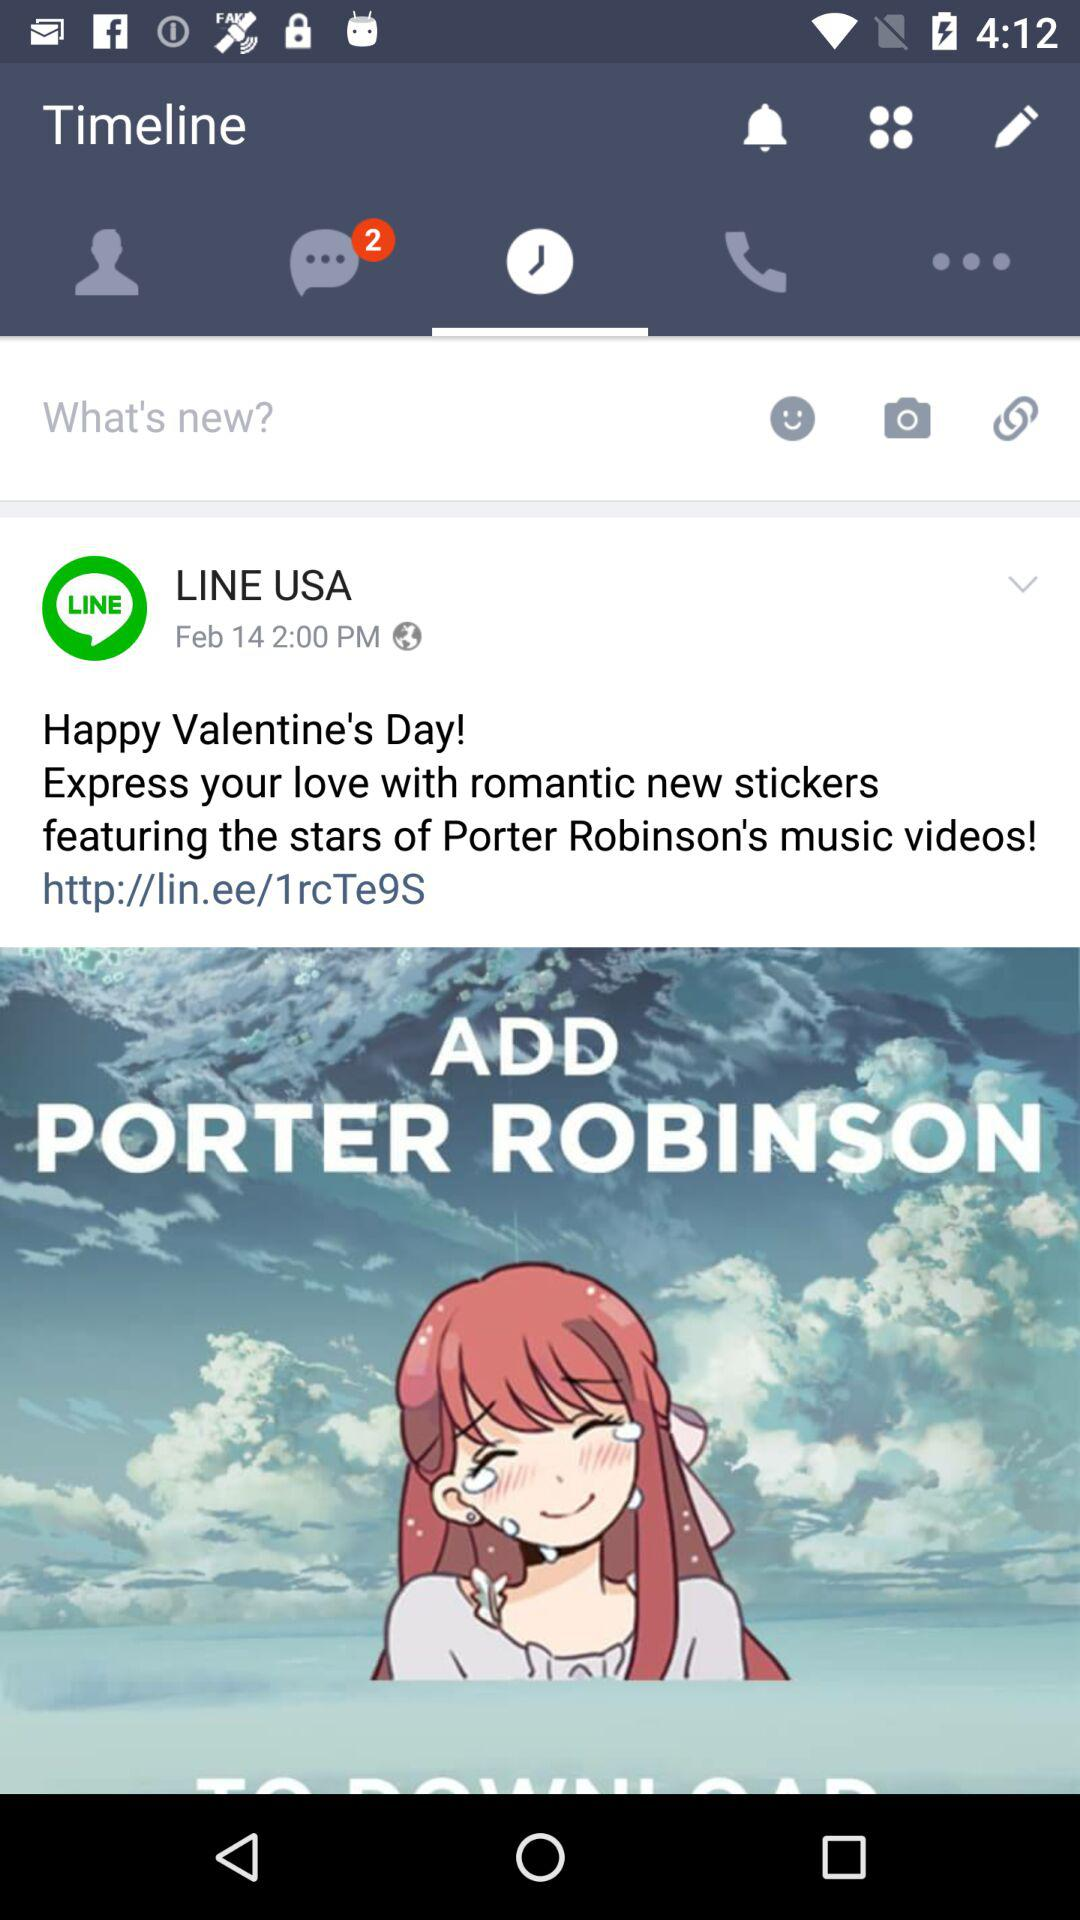What's the post upload date and time by LINE USA? The post upload date and time by LINE USA is February 14, 2:00 PM. 